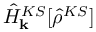<formula> <loc_0><loc_0><loc_500><loc_500>\hat { H } _ { k } ^ { K S } [ \hat { \rho } ^ { K S } ]</formula> 